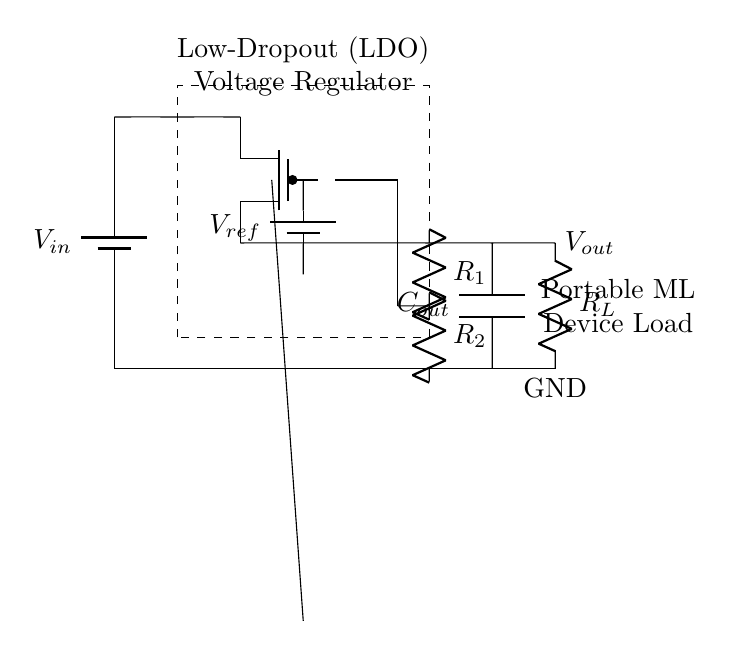What type of regulator is shown in the circuit? The circuit shows a Low-Dropout (LDO) voltage regulator, which is specified in the diagram next to the dashed rectangle.
Answer: Low-Dropout What is the output capacitor labeled in the circuit? The output capacitor is labeled as C_out in the circuit diagram, which is crucial for stabilizing the output voltage.
Answer: C_out What does the feedback network consist of? The feedback network consists of two resistors, R1 and R2, connected in a voltage divider configuration from the output back to the error amplifier.
Answer: R1 and R2 What is the role of the error amplifier? The error amplifier compares the output voltage with a reference voltage to regulate and maintain the desired output level.
Answer: Regulate voltage What is the reference voltage symbol in the circuit? The reference voltage source is denoted as V_ref within the circuit and is essential for the operation of the LDO regulator.
Answer: V_ref Why is it important for a regulator to have a low dropout voltage? A low dropout voltage allows the regulator to maintain output voltage levels even when the input voltage is very close to the desired output level, which is vital in portable ML devices for efficiency.
Answer: Efficiency 